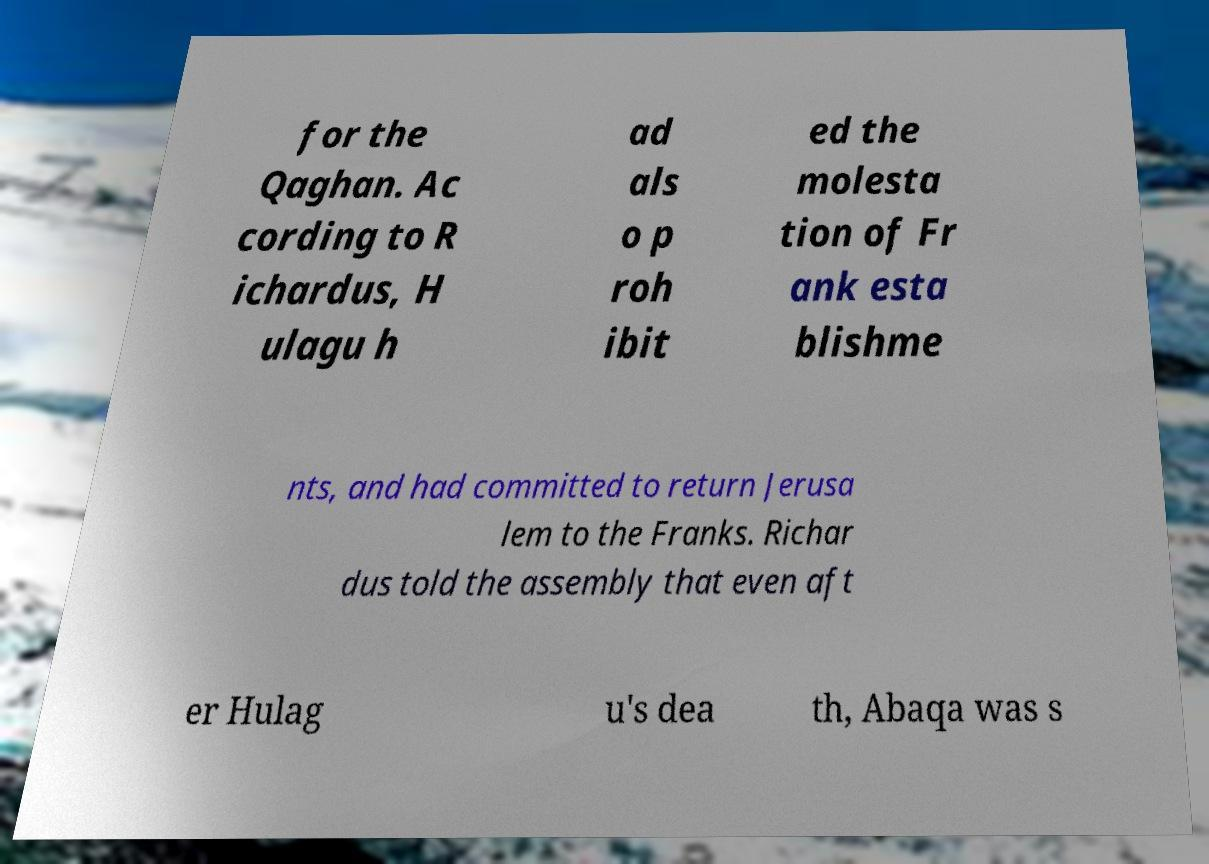Could you extract and type out the text from this image? for the Qaghan. Ac cording to R ichardus, H ulagu h ad als o p roh ibit ed the molesta tion of Fr ank esta blishme nts, and had committed to return Jerusa lem to the Franks. Richar dus told the assembly that even aft er Hulag u's dea th, Abaqa was s 